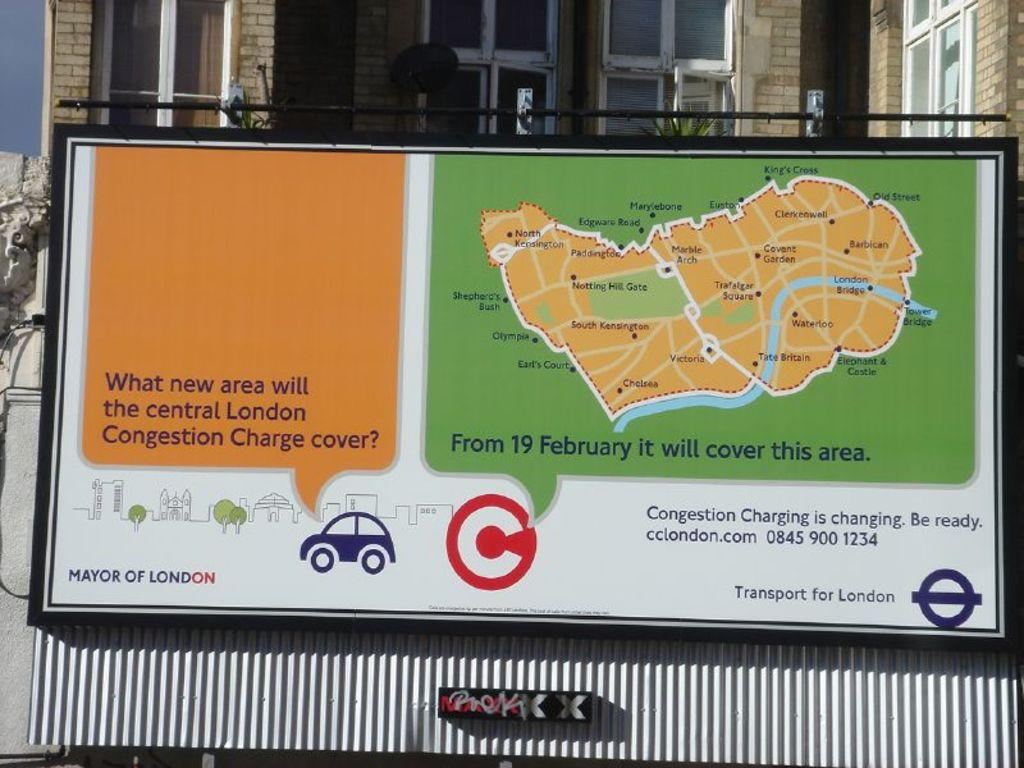What objects are in the foreground of the image? There is a board and a metal sheet in the foreground of the image. What can be seen at the top of the image? There are windows of a building at the top of the image. What type of vegetation is visible in the image? There are plants visible in the image. What architectural feature is present in the image? There is a wall in the image. What type of root can be seen growing from the board in the image? There is no root visible in the image, as it features a board and a metal sheet in the foreground, along with other elements such as windows, plants, and a wall. 